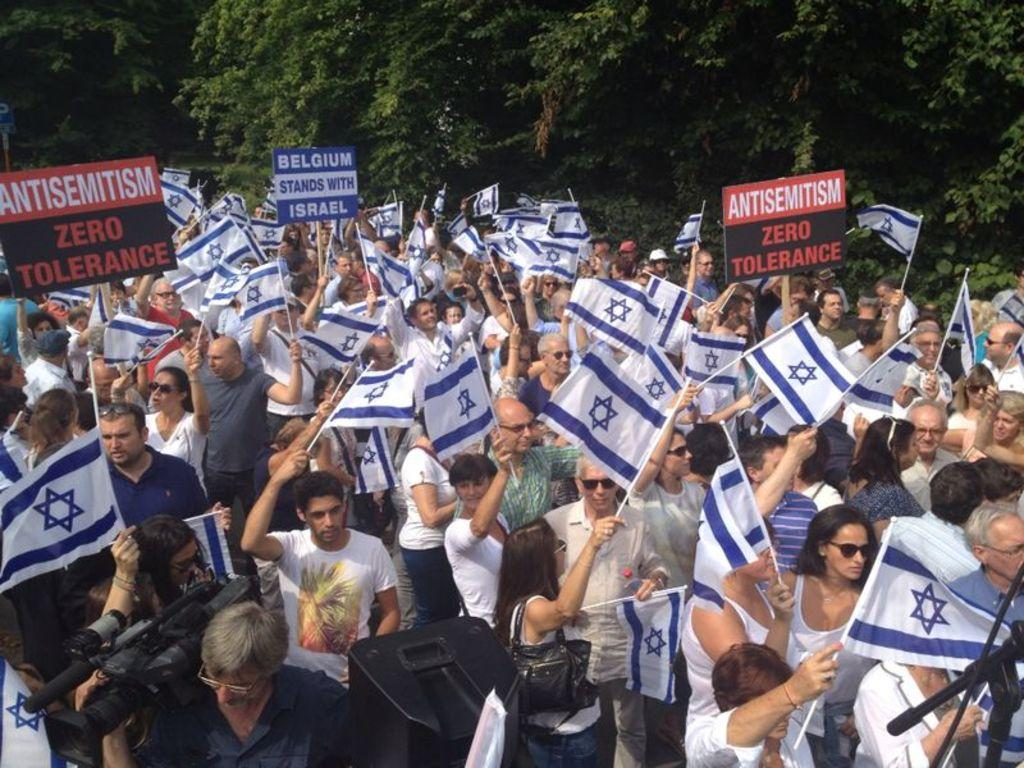What are the people in the image doing? The people in the image are holding flags and boards. What can be seen in the background of the image? There are trees in the background of the image. Can you tell me how many strangers are crying in the cemetery in the image? There is no cemetery or strangers present in the image; it features people holding flags and boards. 